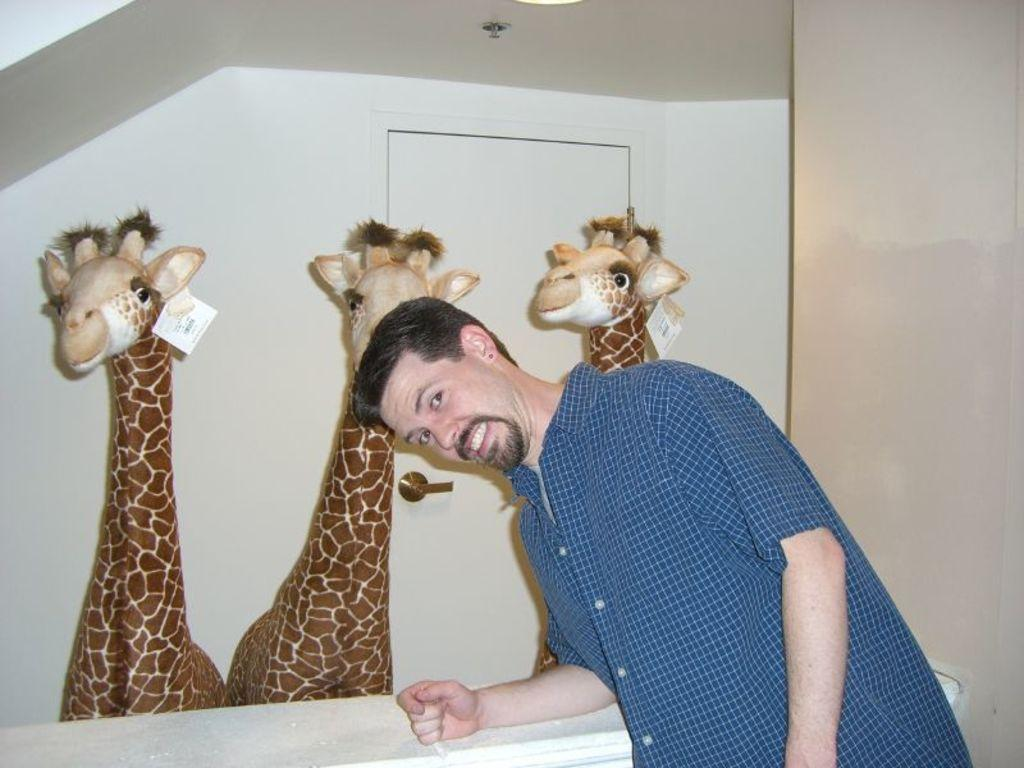Who is the main subject in the image? There is a person standing in the front of the image. What is the person doing in the image? The person is smiling. What can be seen in the center of the image? There are toys in the center of the image. What is visible in the background of the image? There is a wall and a door in the background of the image. How many legs does the plough have in the image? There is no plough present in the image. What type of committee can be seen discussing matters in the image? There is no committee present in the image. 